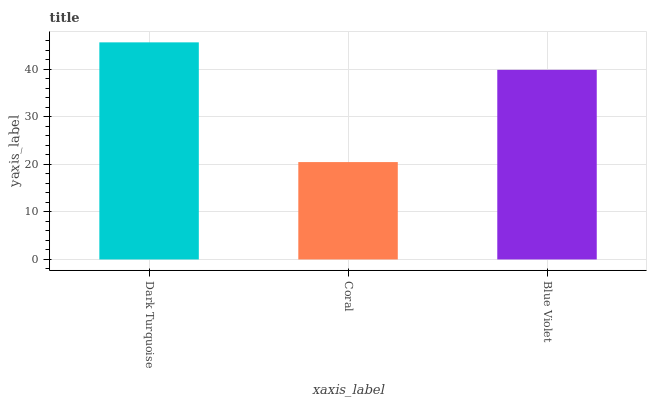Is Coral the minimum?
Answer yes or no. Yes. Is Dark Turquoise the maximum?
Answer yes or no. Yes. Is Blue Violet the minimum?
Answer yes or no. No. Is Blue Violet the maximum?
Answer yes or no. No. Is Blue Violet greater than Coral?
Answer yes or no. Yes. Is Coral less than Blue Violet?
Answer yes or no. Yes. Is Coral greater than Blue Violet?
Answer yes or no. No. Is Blue Violet less than Coral?
Answer yes or no. No. Is Blue Violet the high median?
Answer yes or no. Yes. Is Blue Violet the low median?
Answer yes or no. Yes. Is Coral the high median?
Answer yes or no. No. Is Dark Turquoise the low median?
Answer yes or no. No. 